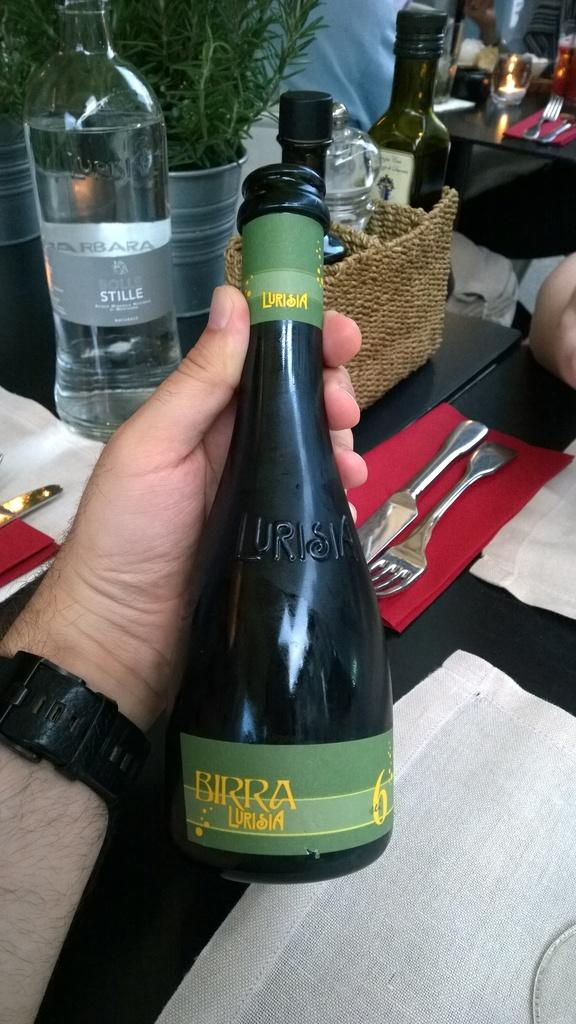Who is present in the image? There is a man in the image. What is the man holding in his hand? The man is holding a bottle in his hand. What else can be seen on the table in front of the man? There are bottles, spoons, and a plant on the table in front of the man. What type of prose is the man reading from the bottle in the image? There is no indication that the man is reading prose from the bottle in the image. 